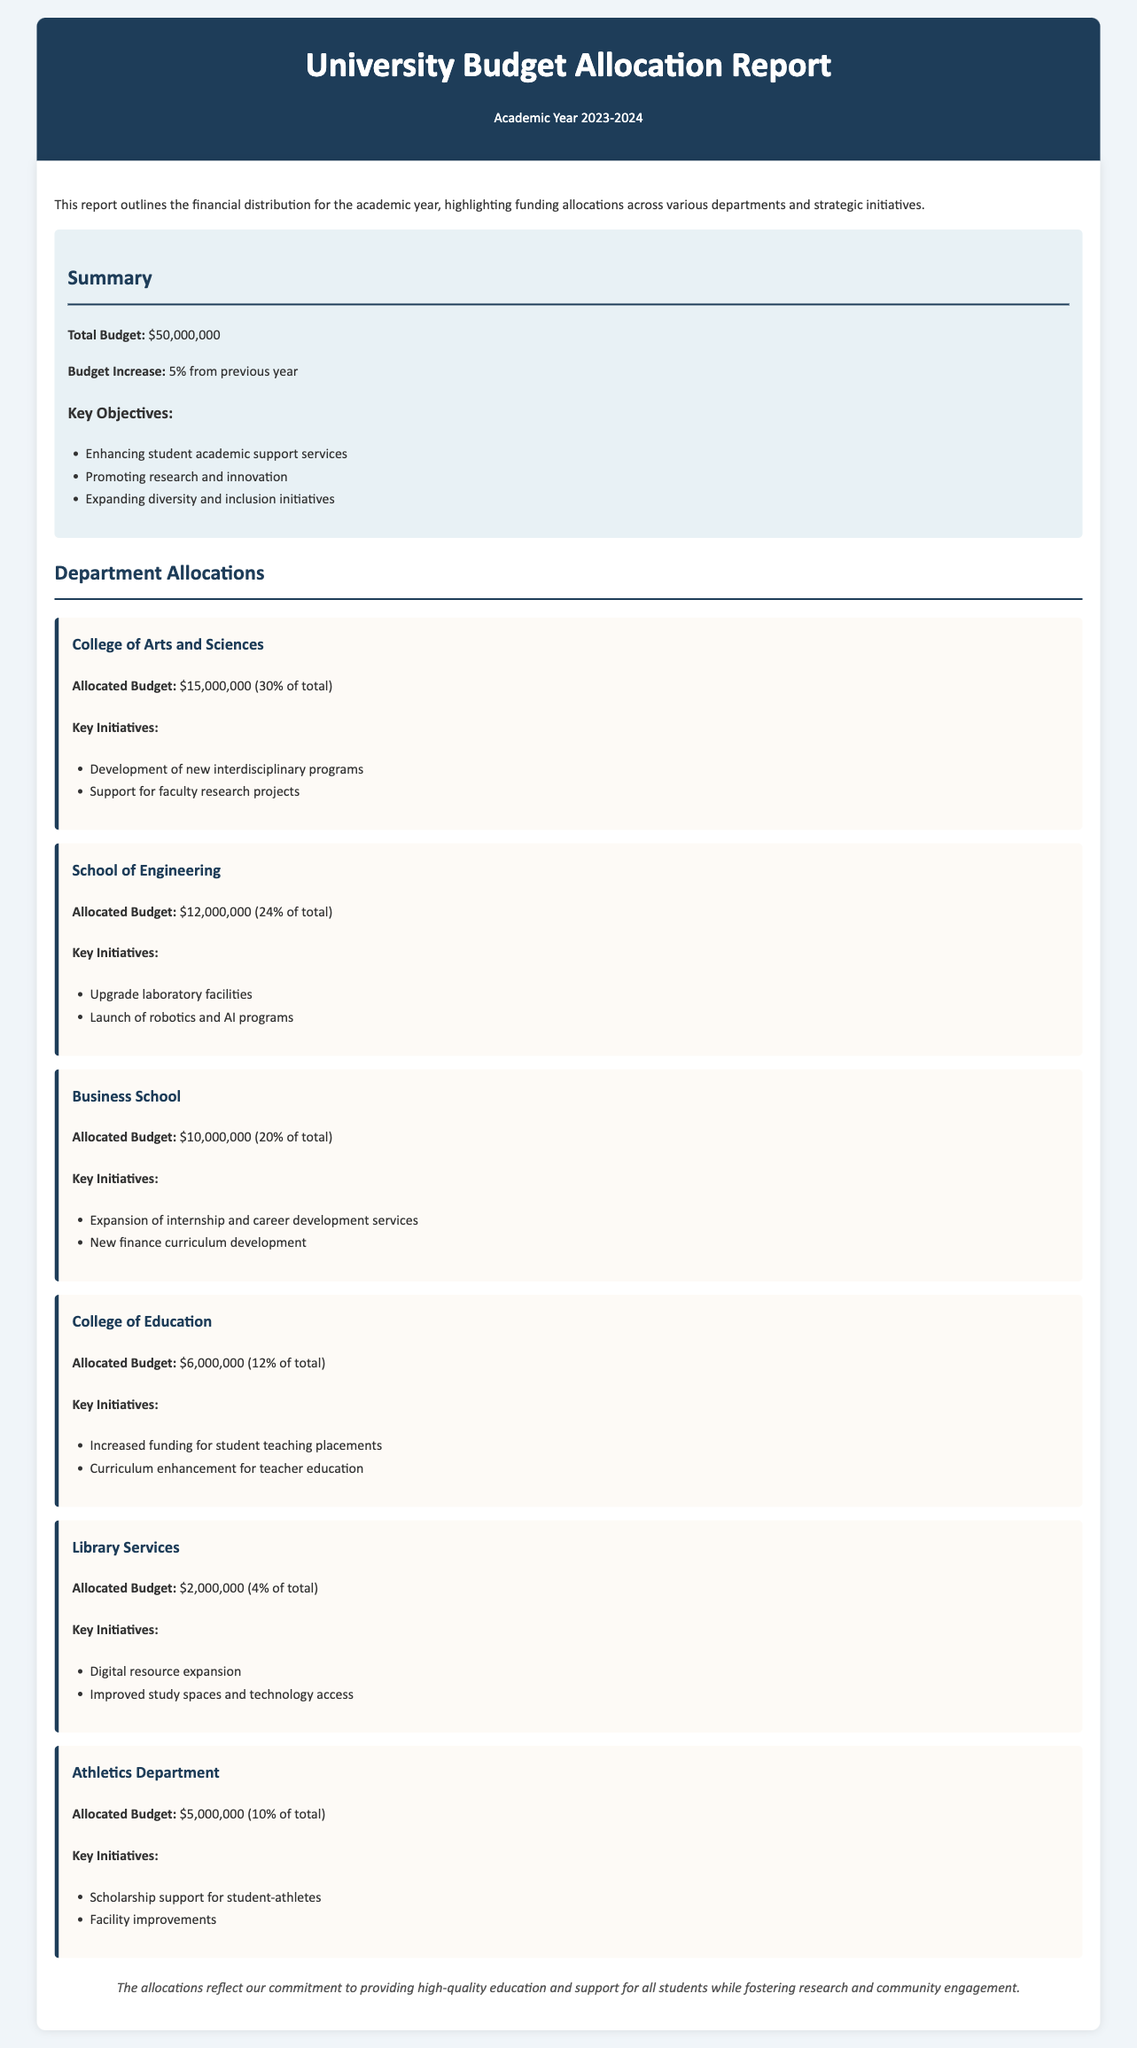What is the total budget for the academic year 2023-2024? The total budget for the academic year is explicitly stated in the document as $50,000,000.
Answer: $50,000,000 Which department received the highest allocation? The document specifies the budget allocation for each department, indicating that the College of Arts and Sciences received the highest with $15,000,000.
Answer: College of Arts and Sciences How much budget is allocated to Library Services? The document details the budget for each department, showing that the Library Services has an allocated budget of $2,000,000.
Answer: $2,000,000 What percentage of the total budget is allocated to the School of Engineering? The School of Engineering's allocation is presented as 24% of the total budget in the document.
Answer: 24% What are the key objectives of the budget outlined in the document? The document lists key objectives, emphasizing enhancing student support, promoting research, and expanding diversity initiatives.
Answer: Enhancing student academic support services, Promoting research and innovation, Expanding diversity and inclusion initiatives Which initiative is mentioned for the Business School? The document highlights two initiatives for the Business School, including the expansion of internship services and new curriculum development.
Answer: Expansion of internship and career development services What is the budget increase percentage compared to the previous year? The document clearly states that the budget has increased by 5% from the previous year.
Answer: 5% What facility improvements are planned for the Athletics Department? The document notes that the Athletics Department is planning facility improvements as part of their budget initiatives.
Answer: Facility improvements How is the summary section of the document structured? The summary section includes total budget figures, percentage increase, and a list of key objectives in bullet points.
Answer: Total Budget, Budget Increase, Key Objectives 